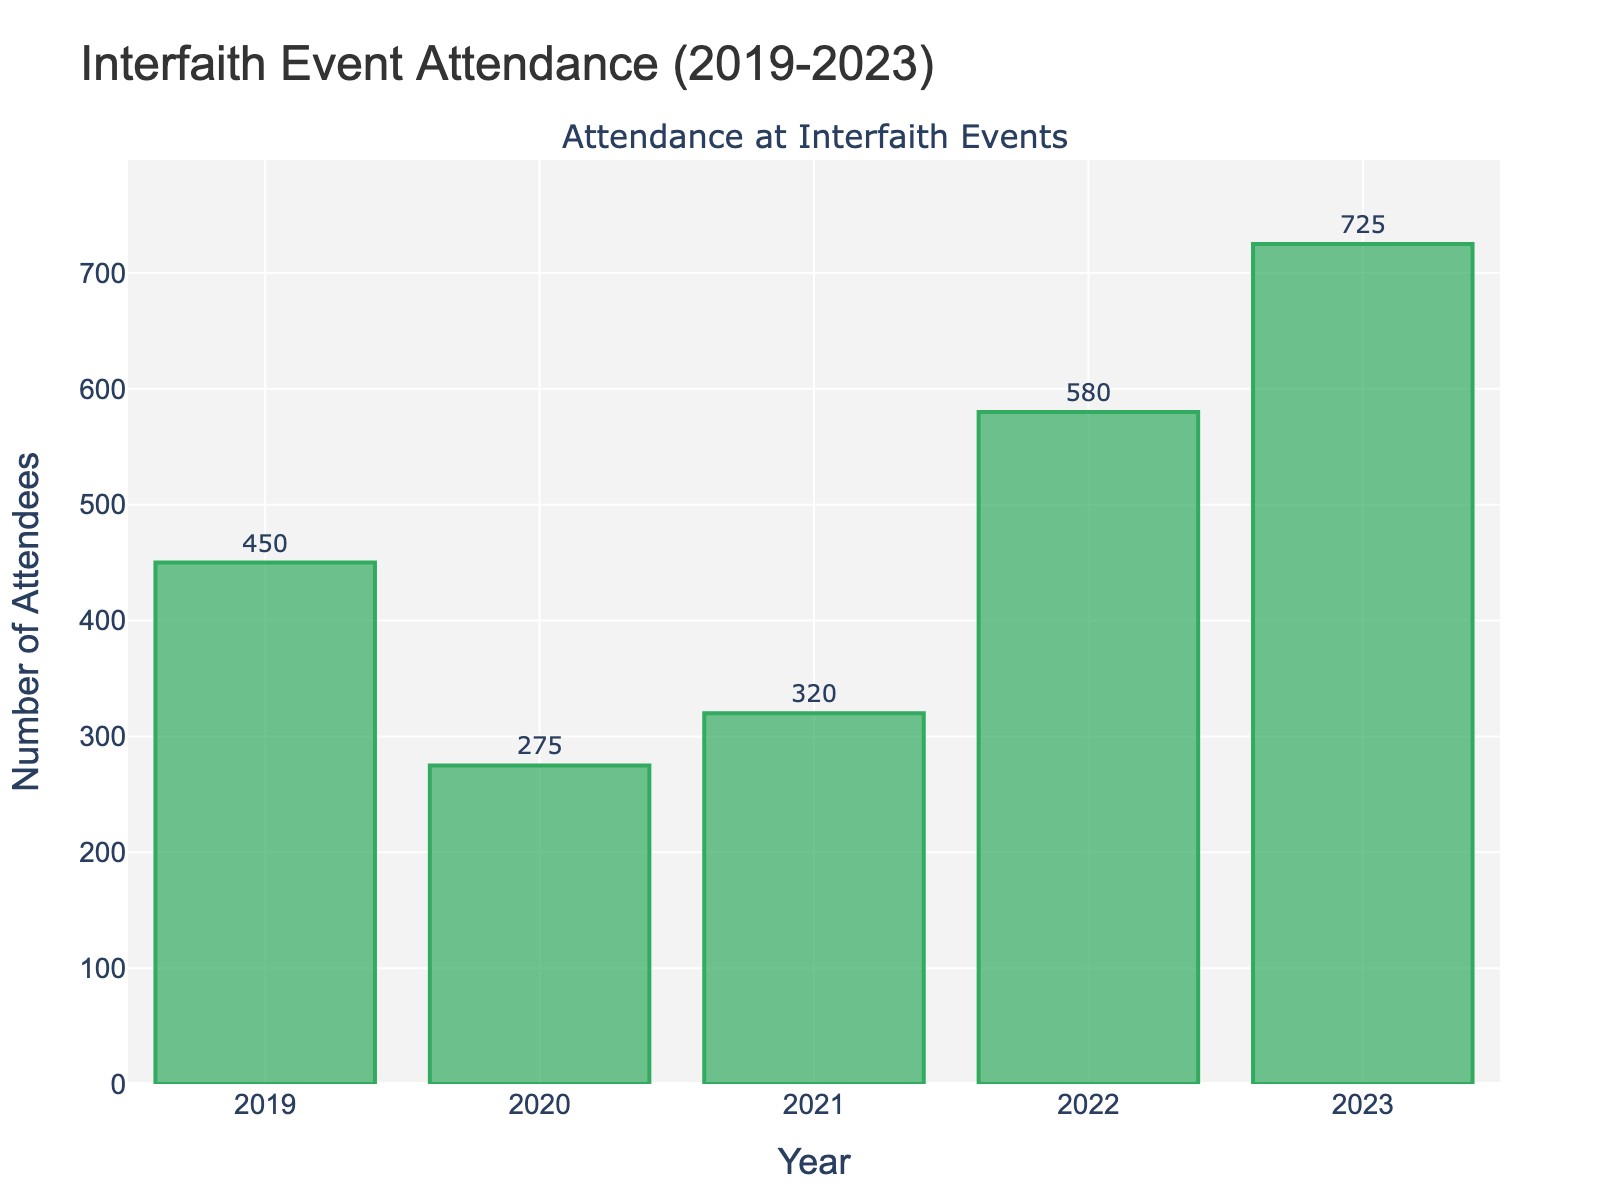How many attendees were there in 2020? Look at the bar for the year 2020 and read the value provided. The text label on the bar indicates 275 attendees.
Answer: 275 How much higher was the attendance in 2023 compared to 2020? Find the attendance values for both 2023 and 2020. The attendance in 2023 was 725, and in 2020 it was 275. Calculate the difference: 725 - 275 = 450.
Answer: 450 What is the total number of attendees over the 5 years shown? Add the attendance values for all years: 450 (2019) + 275 (2020) + 320 (2021) + 580 (2022) + 725 (2023). This gives 450 + 275 + 320 + 580 + 725 = 2350.
Answer: 2350 What was the percentage increase in attendance from 2022 to 2023? Compute the attendance difference between 2022 and 2023: 725 - 580 = 145. Then, divide by the 2022 value and multiply by 100 to get the percentage: (145/580) * 100 ≈ 25.00%.
Answer: 25.00% Which year had the lowest attendance? Compare the heights of the bars or the text labels to find the lowest value. The year 2020 had the lowest attendance with 275 attendees.
Answer: 2020 How does the attendance in 2021 compare to 2019? Look at the attendance values for 2021 and 2019. The value for 2021 is 320, while for 2019 it is 450. Calculate the difference: 450 - 320 = 130. The attendance in 2021 was lower by 130.
Answer: 130 lower In which year did the attendance first exceed 500? Check each year's attendance values sequentially until exceeding 500. The first year to exceed 500 attendees was 2022, with 580 attendees.
Answer: 2022 What’s the average annual attendance over the 5 years? Add the total number of attendees over the 5 years (2350 as previously calculated) and divide by the number of years, which is 5: 2350 / 5 = 470.
Answer: 470 What is the difference in attendance between the highest and lowest attendance years? Identify the highest attendance year (2023 with 725 attendees) and the lowest attendance year (2020 with 275 attendees). Calculate the difference: 725 - 275 = 450.
Answer: 450 